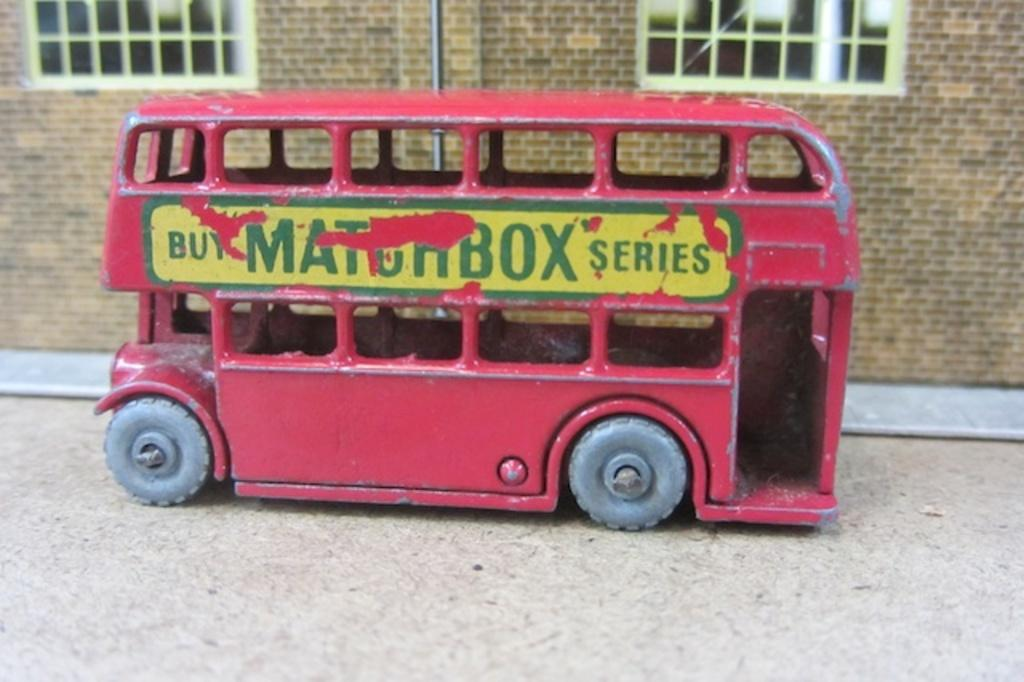What type of toy is present in the image? There is a red toy car in the image. Can you describe the background of the image? There is a building in the background of the image. How many feet are visible in the image? There are no feet visible in the image. What type of support is the toy car resting on in the image? The toy car is not resting on any visible support in the image. 